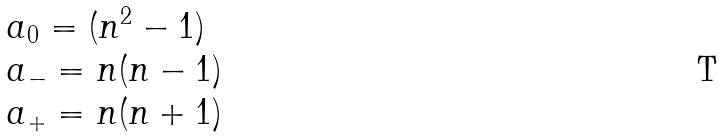<formula> <loc_0><loc_0><loc_500><loc_500>\begin{array} { l c r } { { a _ { 0 } = ( { n ^ { 2 } } - 1 ) } } \\ { { a _ { - } = n ( n - 1 ) } } \\ { { a _ { + } = n ( n + 1 ) } } \end{array}</formula> 